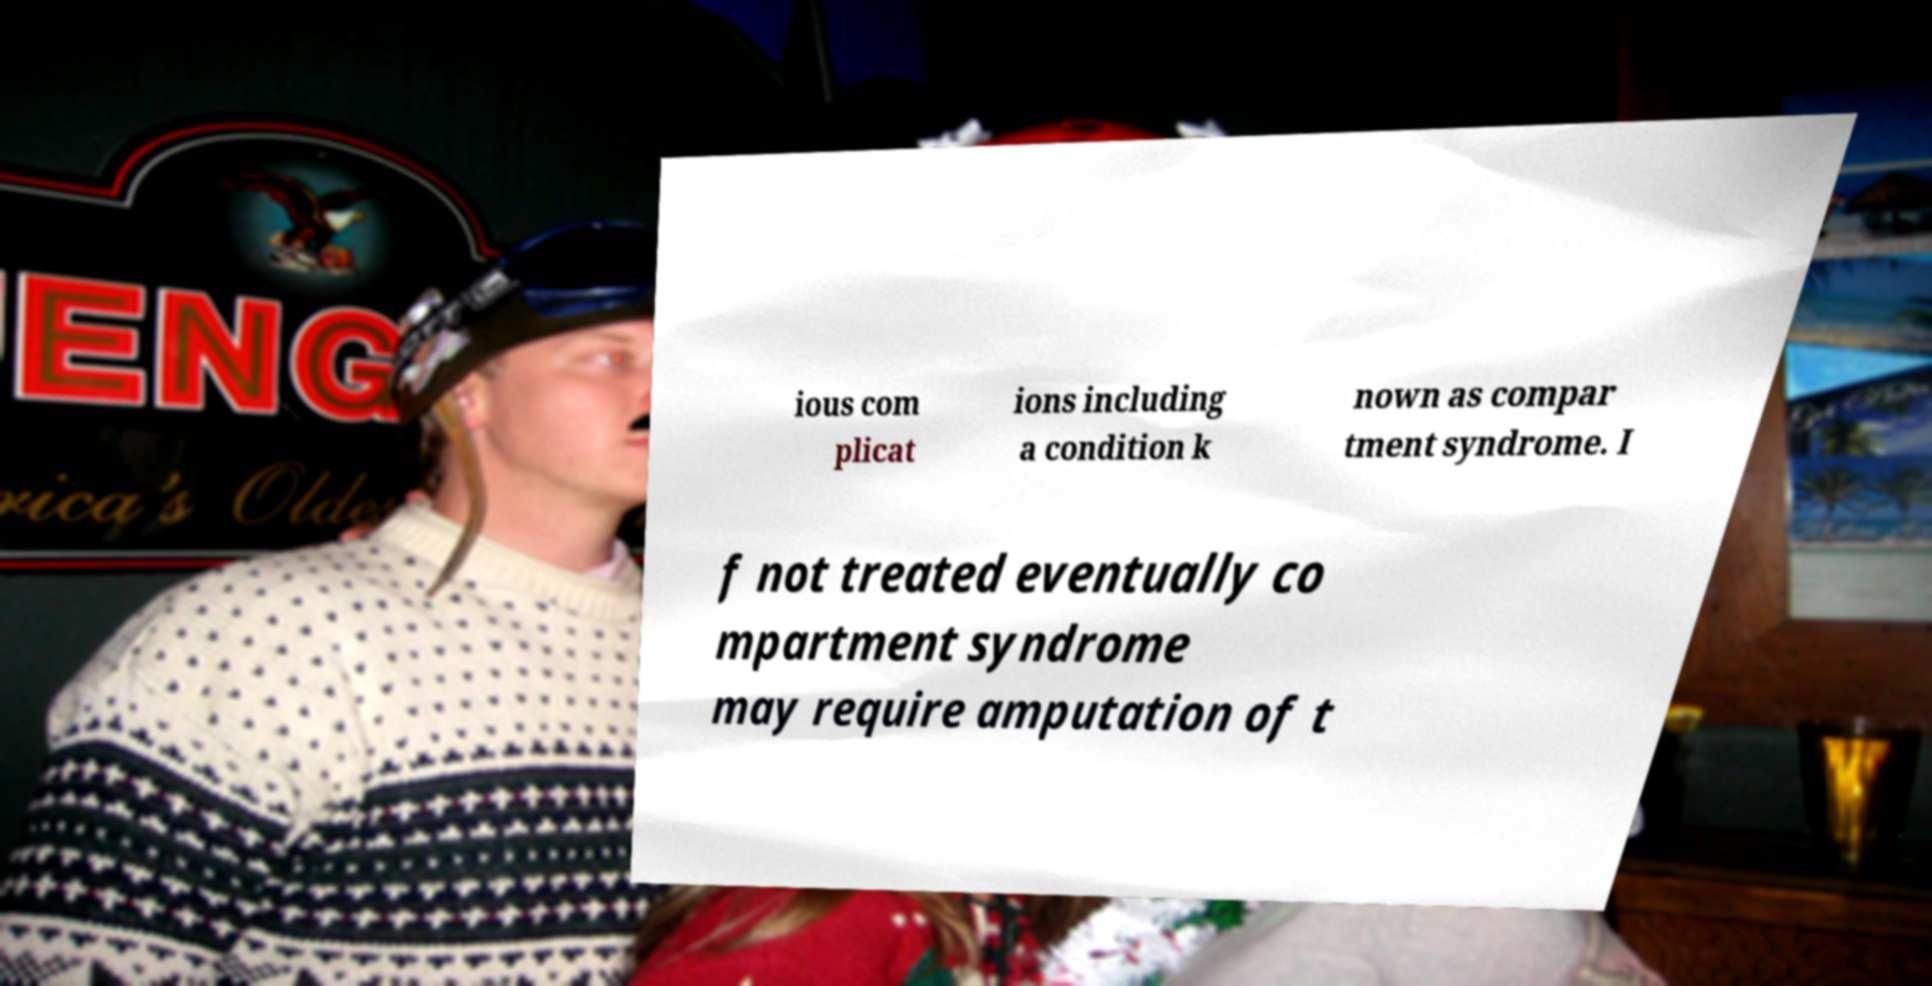Can you read and provide the text displayed in the image?This photo seems to have some interesting text. Can you extract and type it out for me? ious com plicat ions including a condition k nown as compar tment syndrome. I f not treated eventually co mpartment syndrome may require amputation of t 